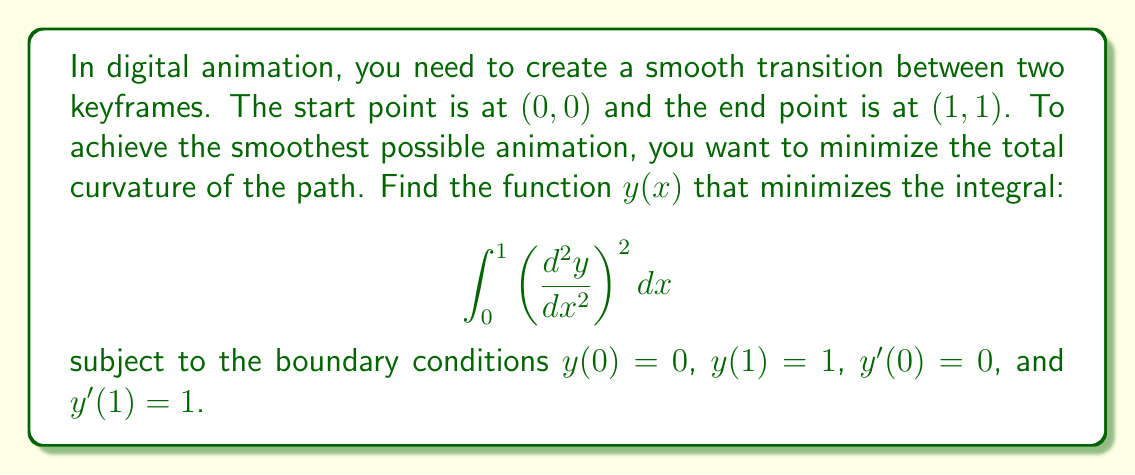Provide a solution to this math problem. To solve this problem, we'll use the calculus of variations approach:

1. The Euler-Lagrange equation for this problem is:
   $$ \frac{d^4y}{dx^4} = 0 $$

2. The general solution to this equation is a cubic polynomial:
   $$ y(x) = ax^3 + bx^2 + cx + d $$

3. Apply the boundary conditions:
   - y(0) = 0 implies d = 0
   - y(1) = 1 implies a + b + c = 1
   - y'(0) = 0 implies c = 0
   - y'(1) = 1 implies 3a + 2b = 1

4. Solve the system of equations:
   $$ \begin{cases}
      a + b = 1 \\
      3a + 2b = 1
   \end{cases} $$

5. The solution is:
   $$ a = \frac{1}{2}, b = \frac{1}{2} $$

6. Therefore, the optimal function is:
   $$ y(x) = \frac{1}{2}x^3 + \frac{1}{2}x^2 $$

This function is known as a cubic Hermite spline, which provides the smoothest transition between the two keyframes while satisfying the given boundary conditions.
Answer: $y(x) = \frac{1}{2}x^3 + \frac{1}{2}x^2$ 